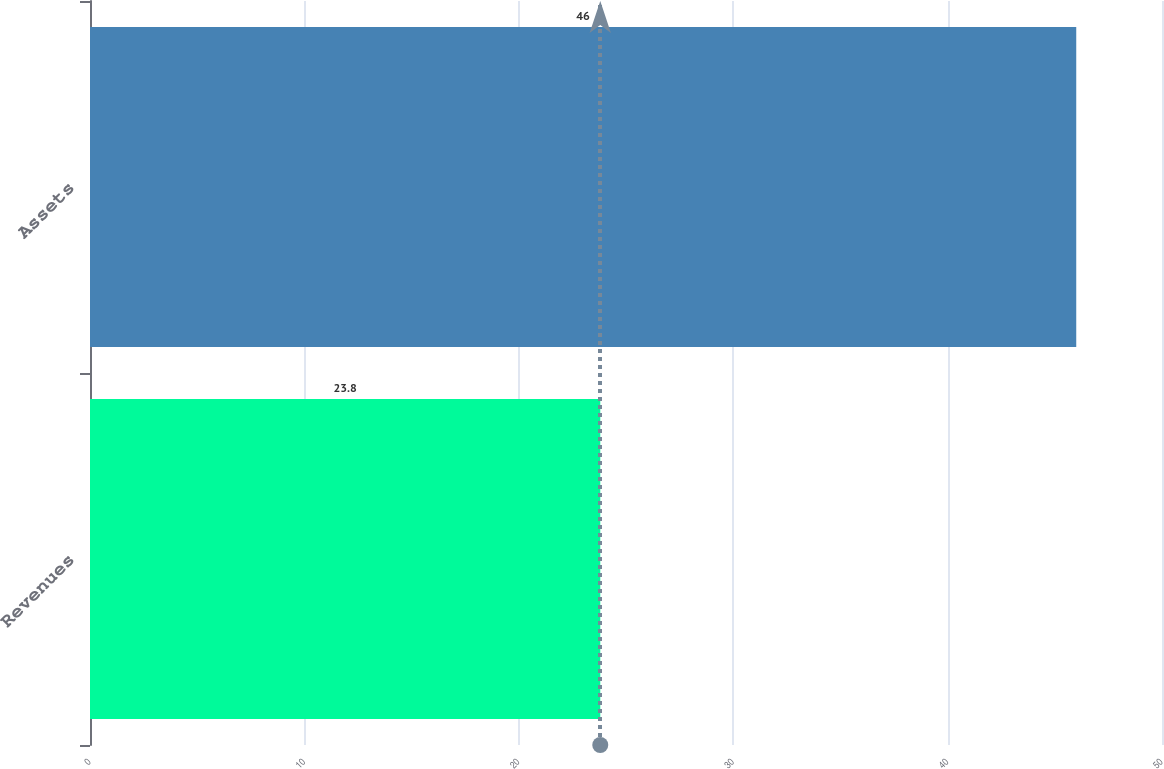<chart> <loc_0><loc_0><loc_500><loc_500><bar_chart><fcel>Revenues<fcel>Assets<nl><fcel>23.8<fcel>46<nl></chart> 